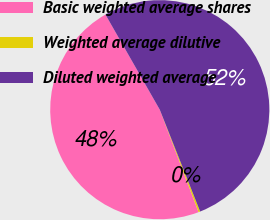Convert chart to OTSL. <chart><loc_0><loc_0><loc_500><loc_500><pie_chart><fcel>Basic weighted average shares<fcel>Weighted average dilutive<fcel>Diluted weighted average<nl><fcel>47.5%<fcel>0.25%<fcel>52.25%<nl></chart> 